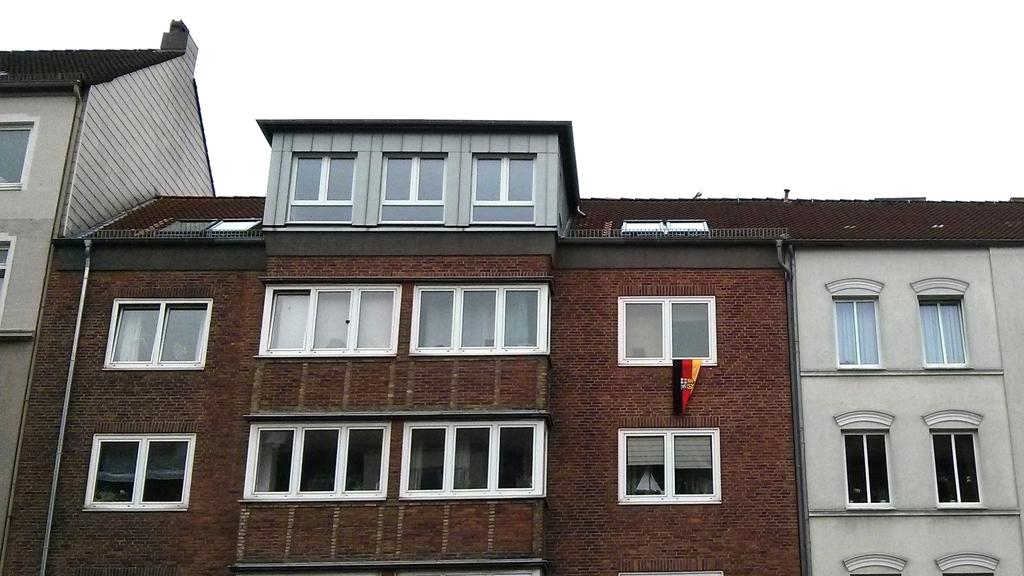What type of structure is present in the image? There is a building in the image. What is the color of the building? The building is brown in color. What type of windows does the building have? The building has glass windows. What type of pencil is being used to draw the building in the image? There is no pencil or drawing present in the image; it is a photograph of an actual building. 